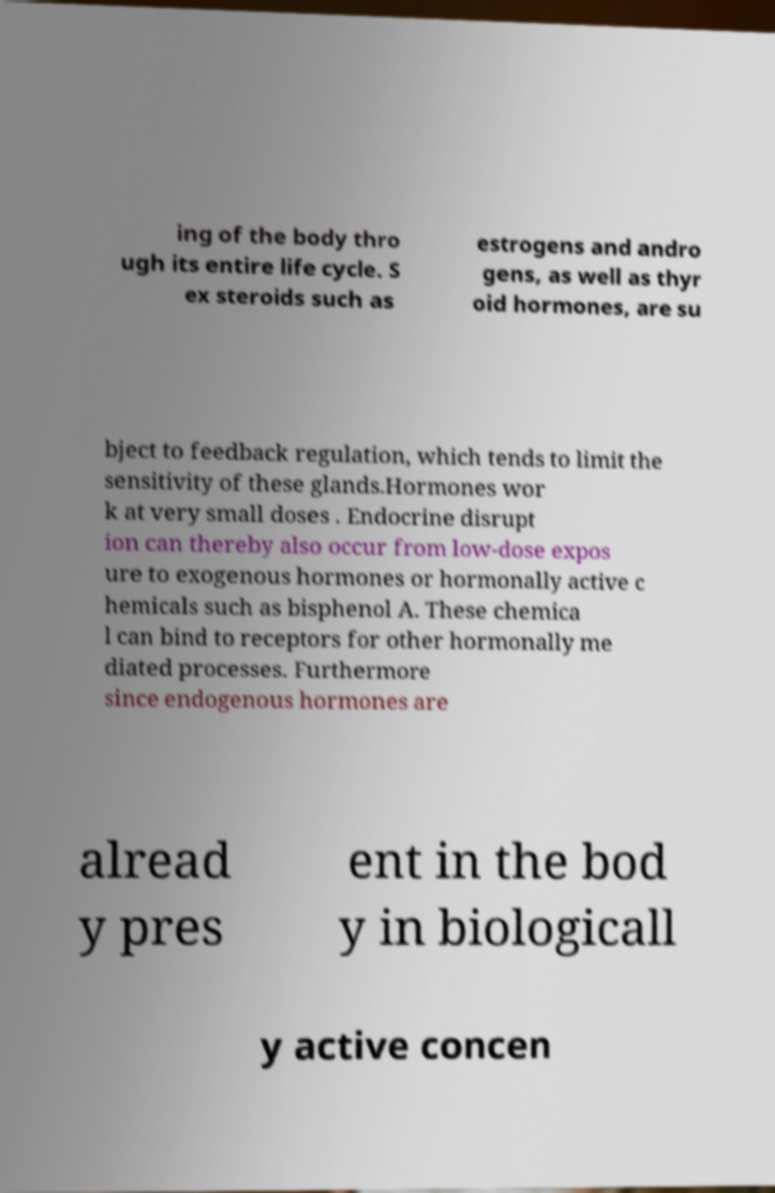For documentation purposes, I need the text within this image transcribed. Could you provide that? ing of the body thro ugh its entire life cycle. S ex steroids such as estrogens and andro gens, as well as thyr oid hormones, are su bject to feedback regulation, which tends to limit the sensitivity of these glands.Hormones wor k at very small doses . Endocrine disrupt ion can thereby also occur from low-dose expos ure to exogenous hormones or hormonally active c hemicals such as bisphenol A. These chemica l can bind to receptors for other hormonally me diated processes. Furthermore since endogenous hormones are alread y pres ent in the bod y in biologicall y active concen 